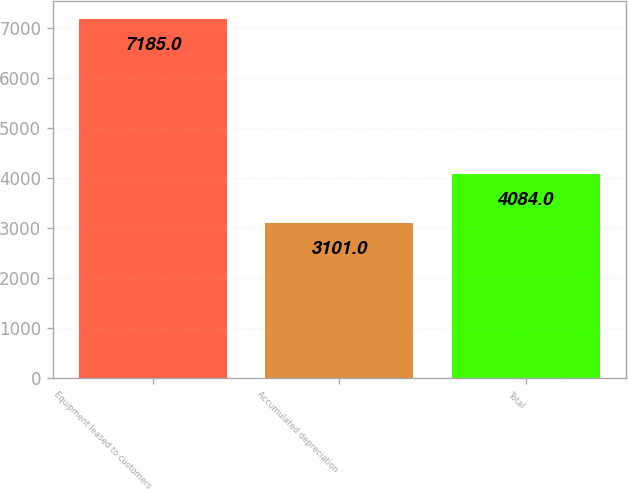Convert chart. <chart><loc_0><loc_0><loc_500><loc_500><bar_chart><fcel>Equipment leased to customers<fcel>Accumulated depreciation<fcel>Total<nl><fcel>7185<fcel>3101<fcel>4084<nl></chart> 